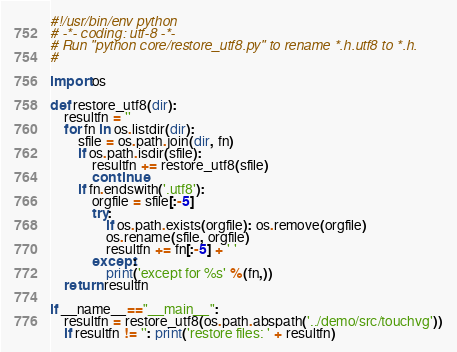Convert code to text. <code><loc_0><loc_0><loc_500><loc_500><_Python_>#!/usr/bin/env python
# -*- coding: utf-8 -*-
# Run "python core/restore_utf8.py" to rename *.h.utf8 to *.h.
#

import os

def restore_utf8(dir):
    resultfn = ''
    for fn in os.listdir(dir):
        sfile = os.path.join(dir, fn)
        if os.path.isdir(sfile):
            resultfn += restore_utf8(sfile)
            continue
        if fn.endswith('.utf8'):
            orgfile = sfile[:-5]
            try:
                if os.path.exists(orgfile): os.remove(orgfile)
                os.rename(sfile, orgfile)
                resultfn += fn[:-5] + ' '
            except:
                print('except for %s' %(fn,))
    return resultfn

if __name__=="__main__":
    resultfn = restore_utf8(os.path.abspath('../demo/src/touchvg'))
    if resultfn != '': print('restore files: ' + resultfn)
</code> 